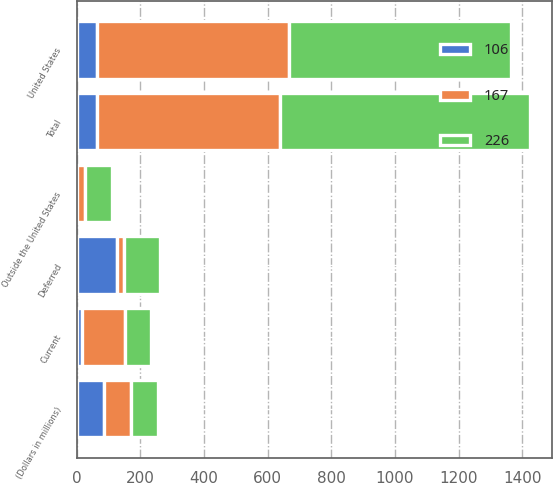Convert chart to OTSL. <chart><loc_0><loc_0><loc_500><loc_500><stacked_bar_chart><ecel><fcel>(Dollars in millions)<fcel>United States<fcel>Outside the United States<fcel>Total<fcel>Current<fcel>Deferred<nl><fcel>167<fcel>85<fcel>602<fcel>26<fcel>576<fcel>136<fcel>22<nl><fcel>226<fcel>85<fcel>698<fcel>85<fcel>783<fcel>80<fcel>112<nl><fcel>106<fcel>85<fcel>65<fcel>1<fcel>64<fcel>16<fcel>128<nl></chart> 